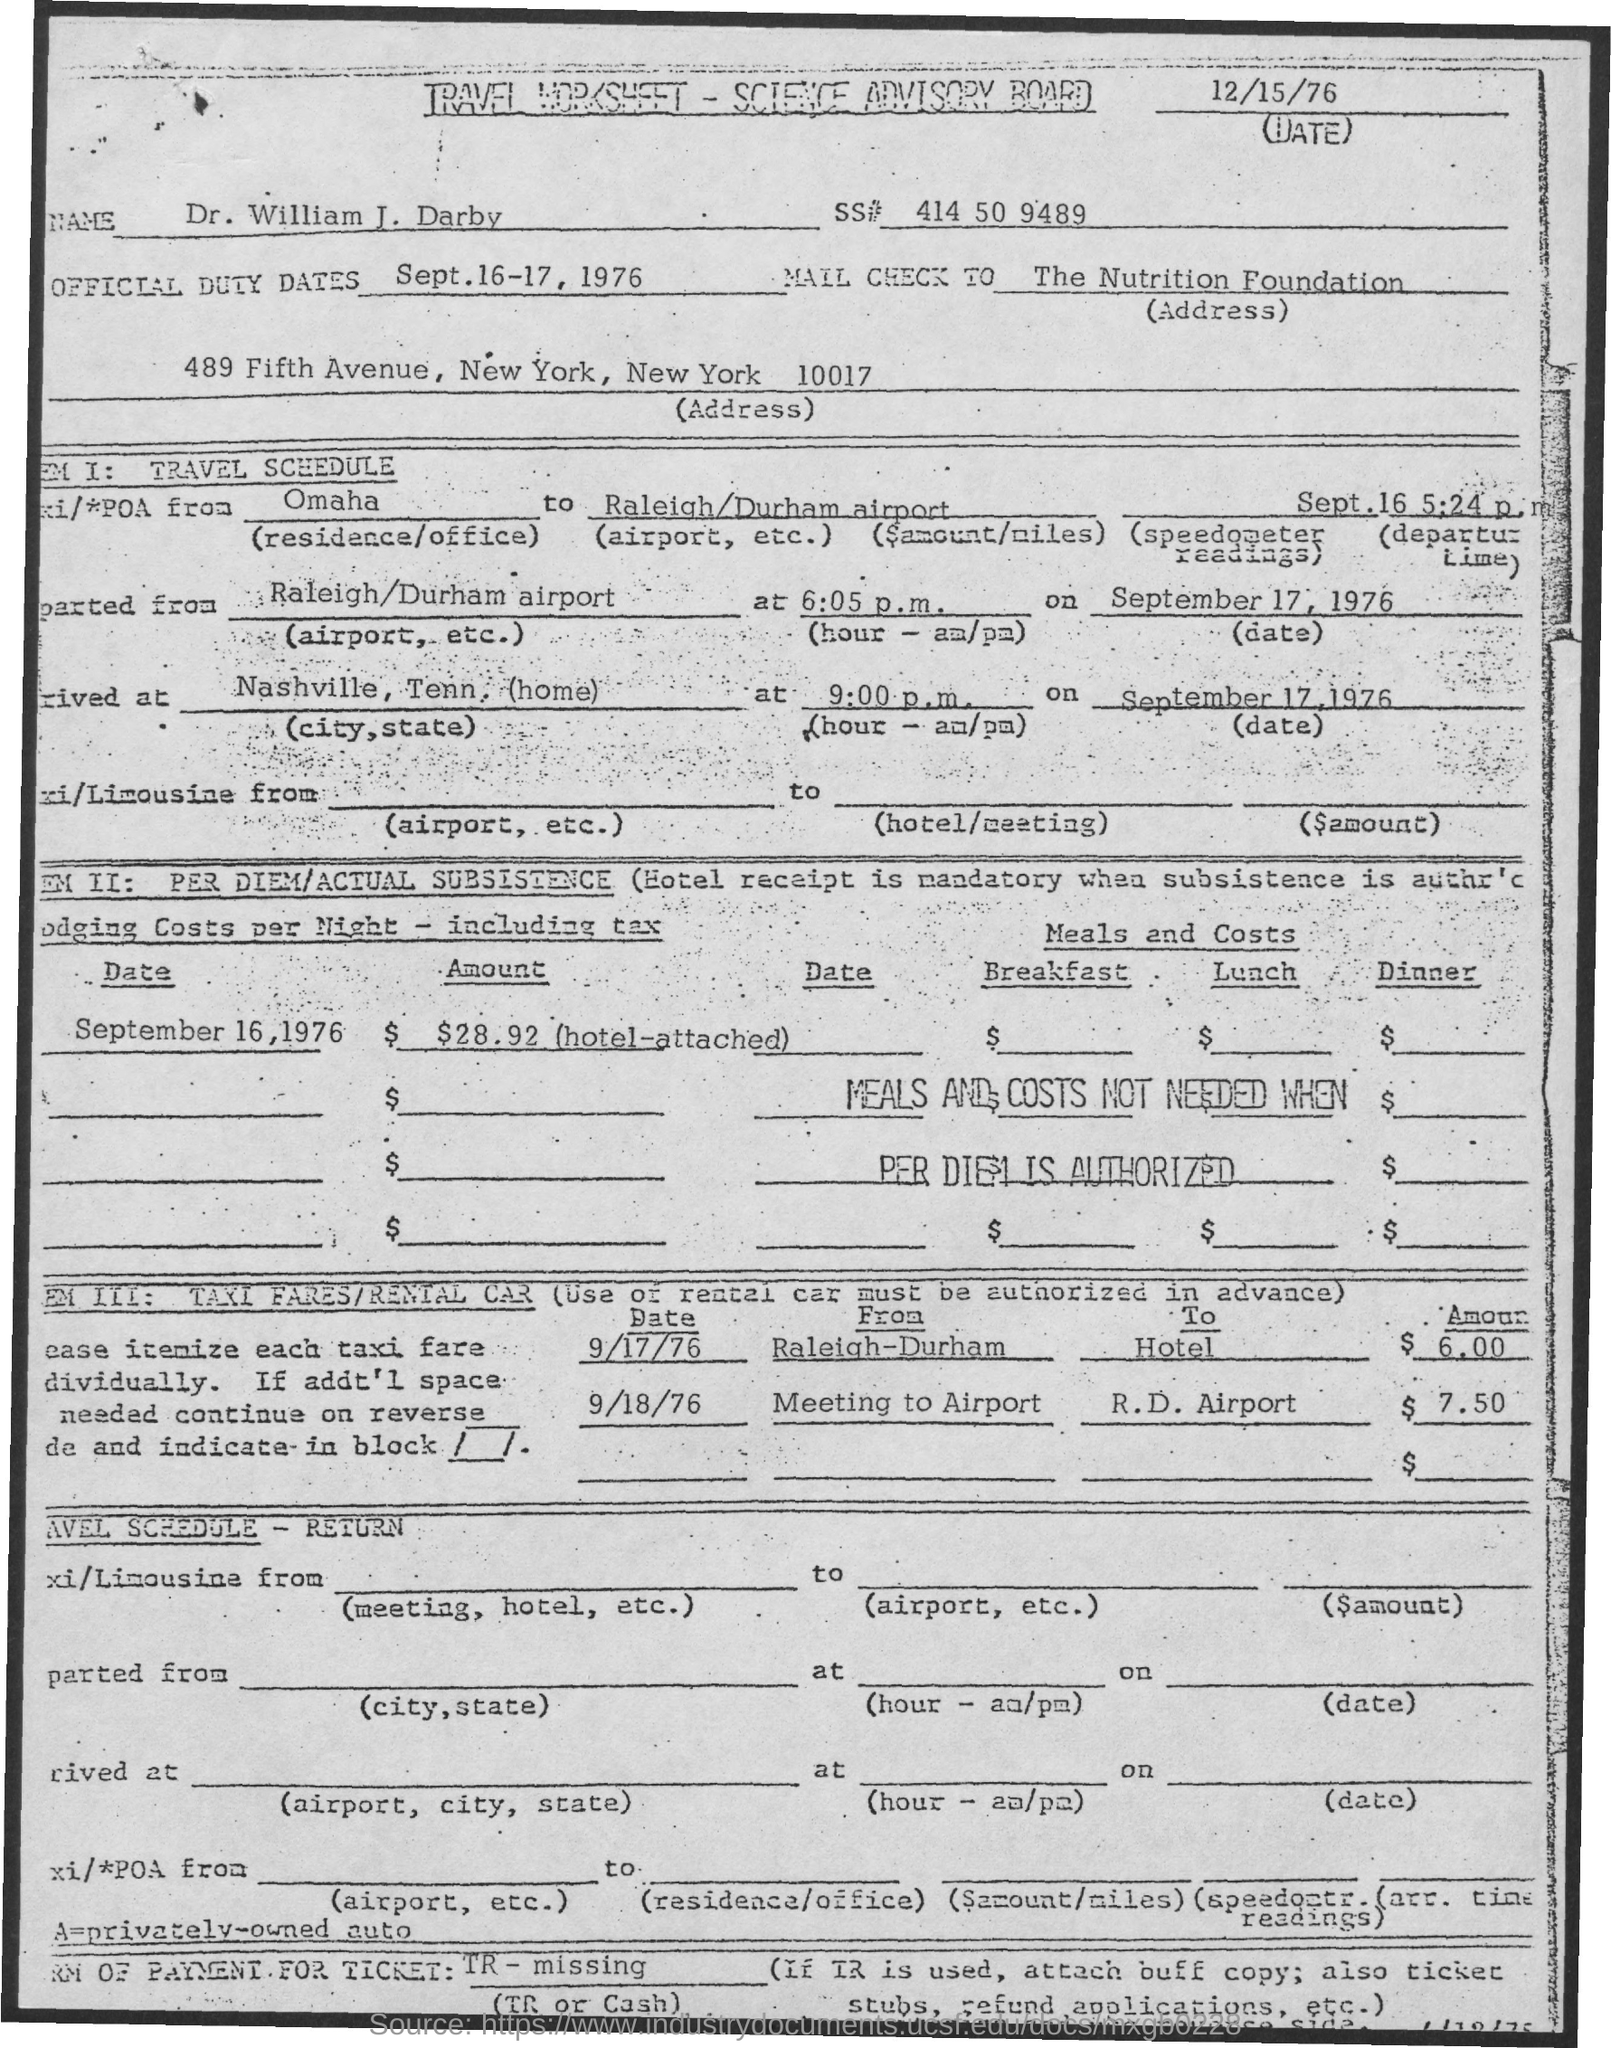List a handful of essential elements in this visual. What is the Official Duty Dates for September 16-17, 1976? On September 17, 1976, the taxi was heading towards the hotel. It is necessary for the check to be sent to The Nutrition Foundation. On September 17, 1976, the taxi fare was $6.00. On 9/17/76, the taxi was traveling from Raleigh-Durham. 